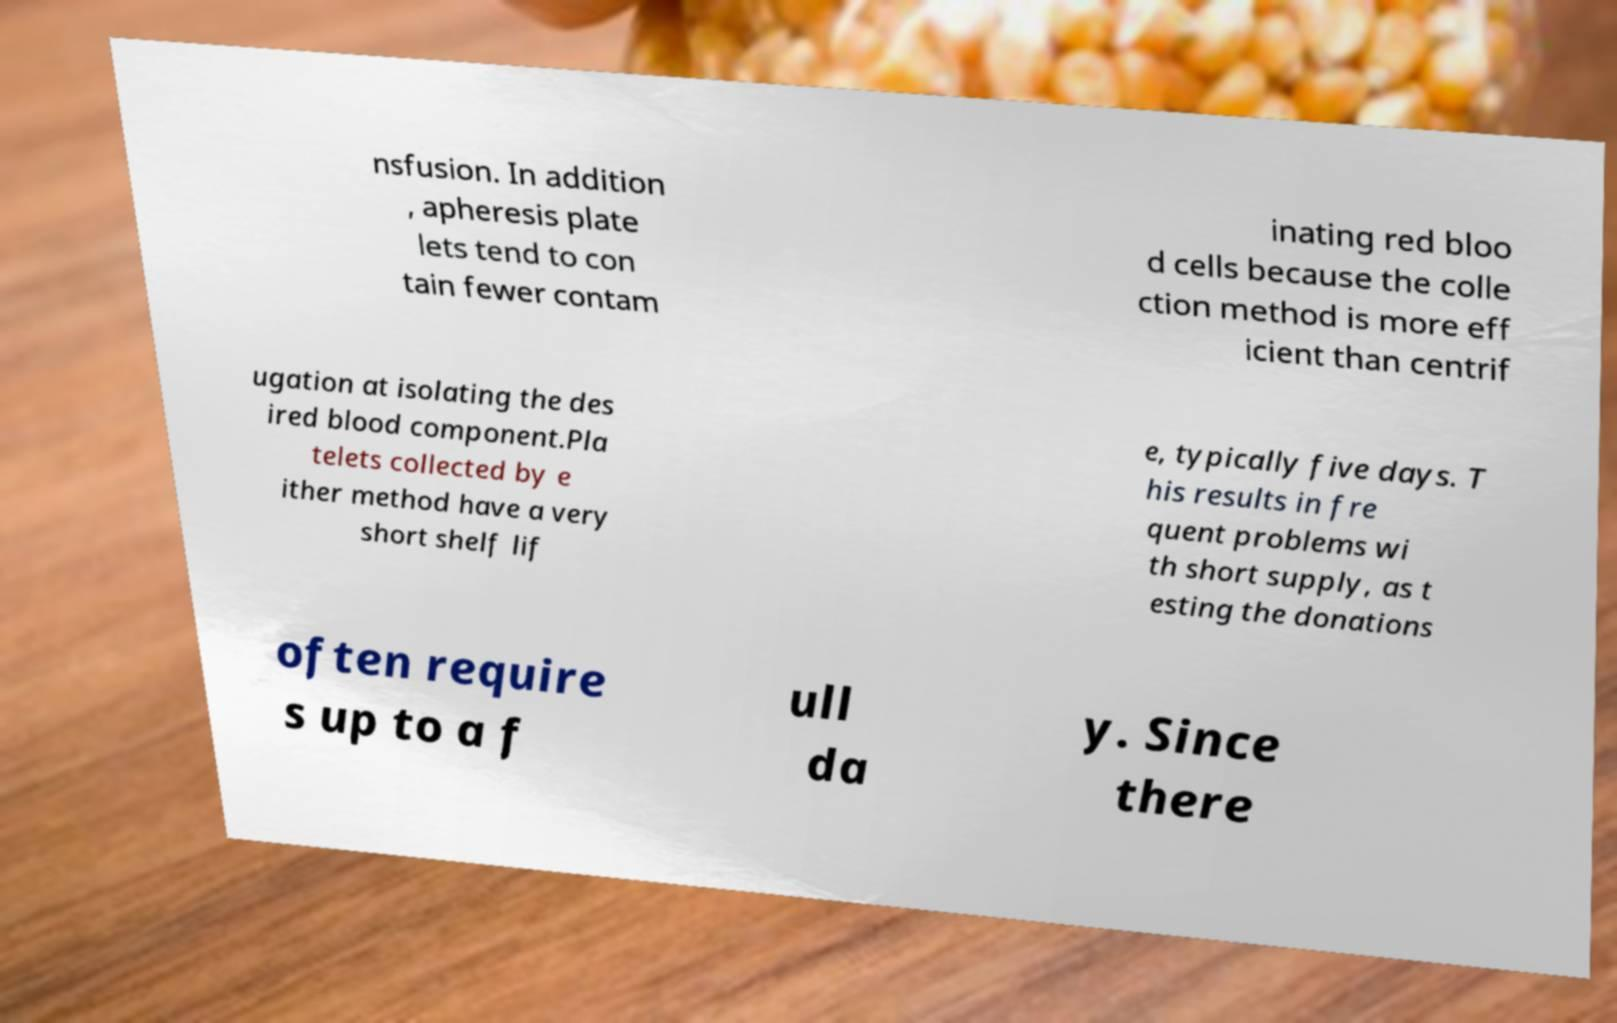Can you read and provide the text displayed in the image?This photo seems to have some interesting text. Can you extract and type it out for me? nsfusion. In addition , apheresis plate lets tend to con tain fewer contam inating red bloo d cells because the colle ction method is more eff icient than centrif ugation at isolating the des ired blood component.Pla telets collected by e ither method have a very short shelf lif e, typically five days. T his results in fre quent problems wi th short supply, as t esting the donations often require s up to a f ull da y. Since there 